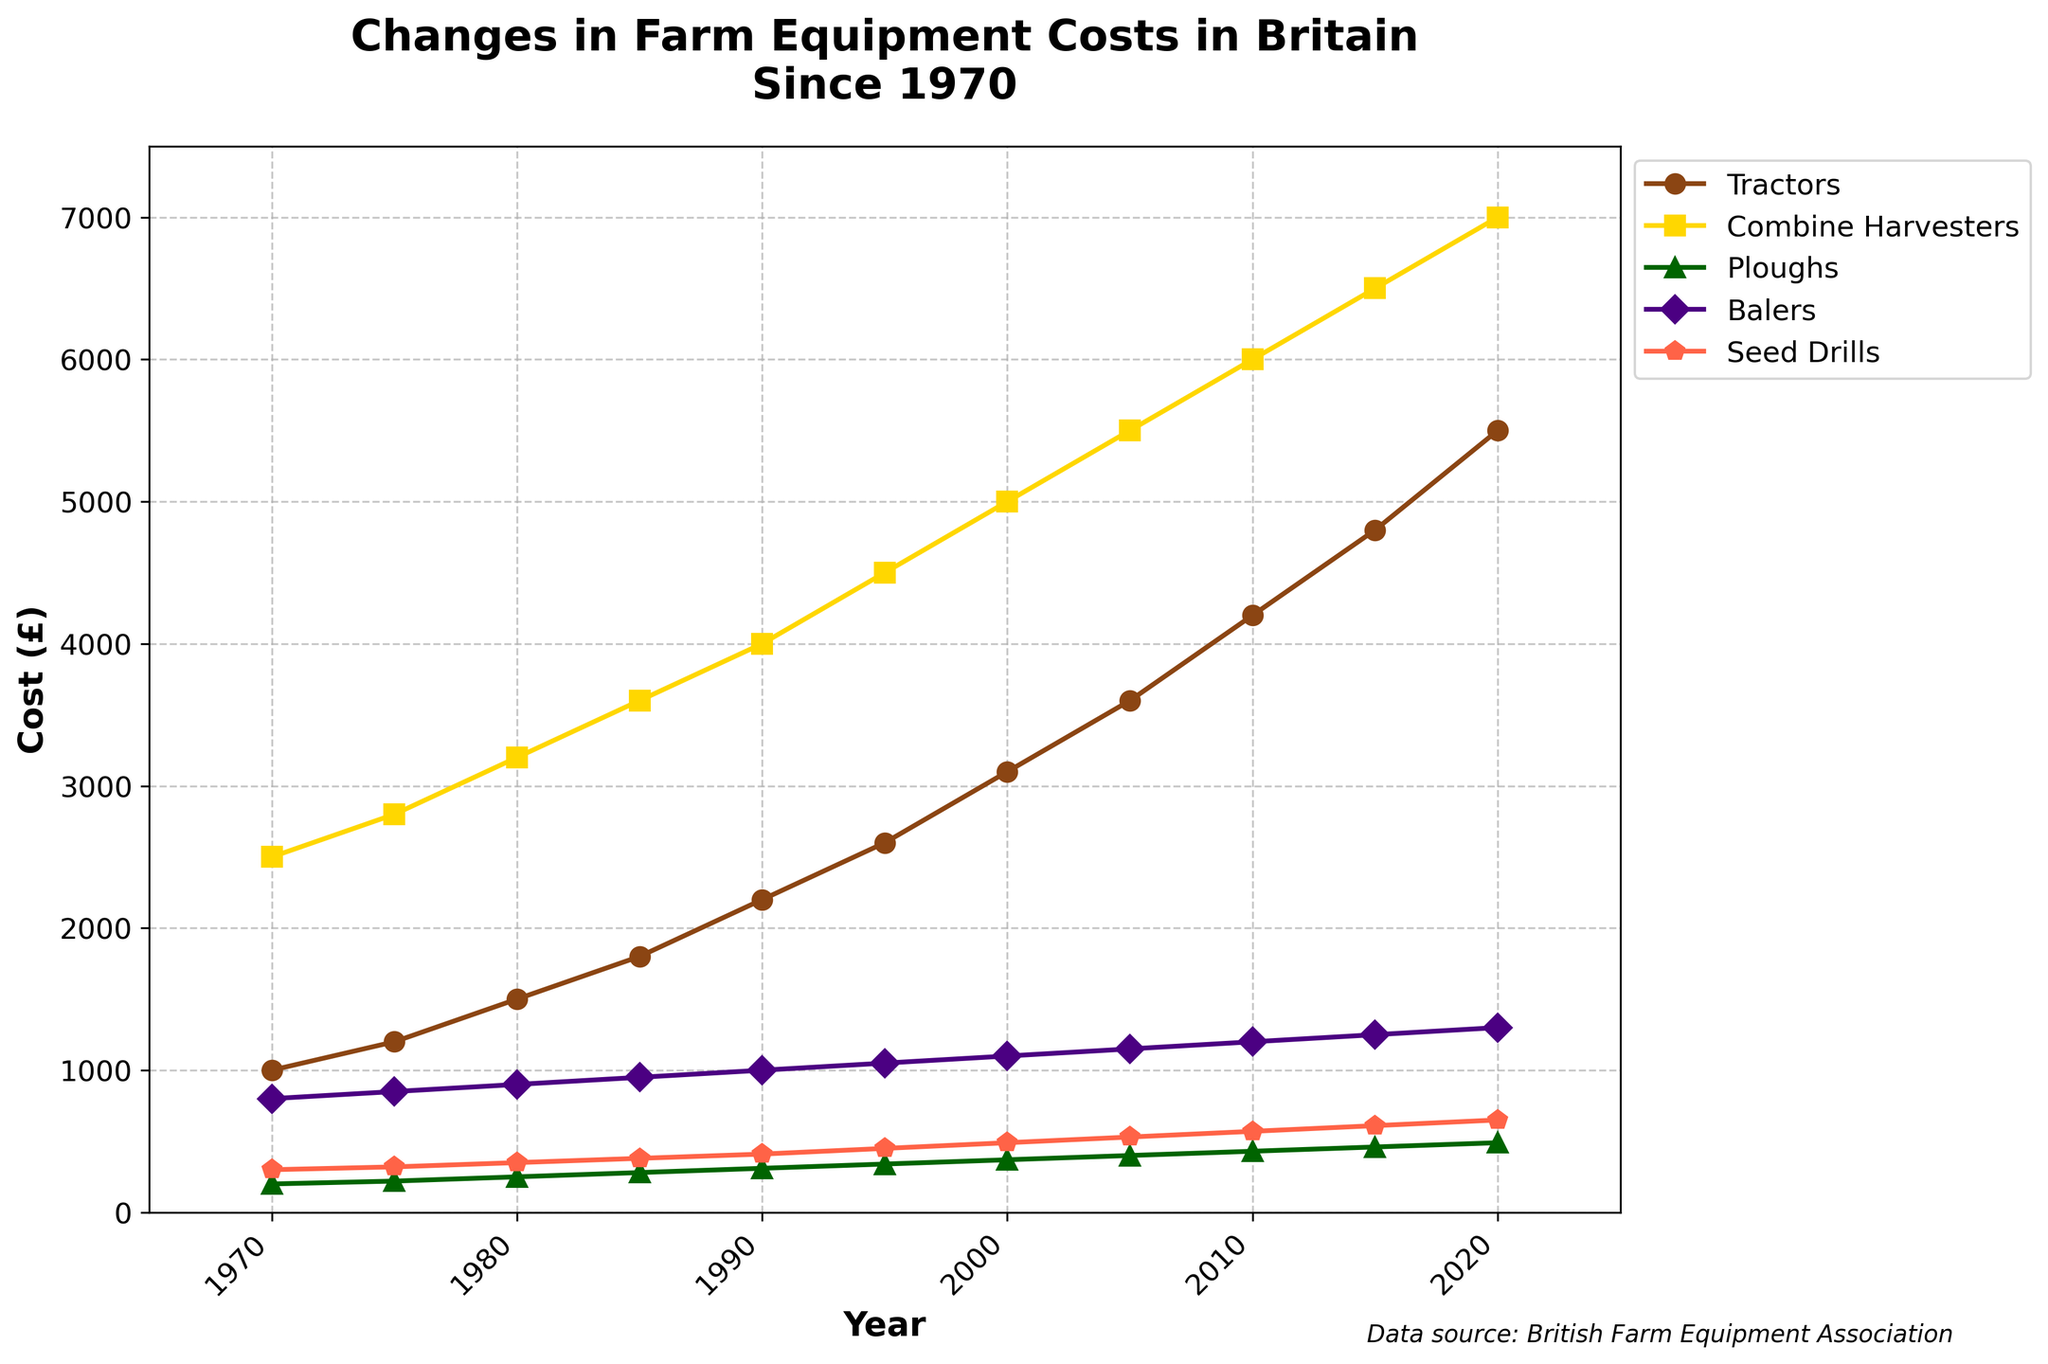What's the trend in the cost of tractors over the years? To determine the trend, look at how the data points for tractors change from 1970 to 2020. The costs increase steadily from £1,000 in 1970 to £5,500 in 2020.
Answer: Increasing Which machinery type had the lowest cost in 1970? From the figure, we can compare the costs of different machinery types in 1970. The ploughs had the lowest cost at £200.
Answer: Ploughs Between 2000 and 2010, which equipment type saw the greatest increase in cost? Calculate the cost increase for each equipment type from 2000 to 2010. Tractors increased by £1,100, Combine Harvesters by £1,000, Ploughs by £60, Balers by £100, and Seed Drills by £80. The greatest increase is for tractors.
Answer: Tractors How much did the cost of Seed Drills change from 1970 to 2020? For Seed Drills, subtract the 1970 cost from the 2020 cost: £650 - £300 = £350.
Answer: £350 Compare the costs of Combine Harvesters and Seed Drills in 1990. Which was more expensive and by how much? In 1990, Combine Harvesters cost £4,000, and Seed Drills cost £410. The difference is £4,000 - £410 = £3,590, with Combine Harvesters being more expensive.
Answer: Combine Harvesters by £3,590 What is the average cost of balers over the years shown? To find the average cost, add all the values from 1970 to 2020 and divide by the number of years: (800+850+900+950+1000+1050+1100+1150+1200+1250+1300)/11 = 1036.36.
Answer: £1036.36 In what year did the cost of Ploughs surpass £300? Review the costs of Ploughs over the years. The cost surpassed £300 in 1990.
Answer: 1990 Which equipment had the steady increase in cost from 1970 to 2020 and never decreased? Examining the plot shows that all machinery types (Tractors, Combine Harvesters, Ploughs, Balers, Seed Drills) show a steady increase in cost without any decrease.
Answer: All What is the difference in cost between the most and the least expensive machinery types in 2020? In 2020, the most expensive machinery type is Combine Harvesters at £7,000, and the least expensive is Ploughs at £490. The difference is £7,000 - £490 = £6,510.
Answer: £6,510 During which interval did the cost of tractors increase the most significantly; 1970-1990 or 2000-2020? Calculate the increase for each interval: 1970-1990 is £2,200 - £1,000 = £1,200 and 2000-2020 is £5,500 - £3,100 = £2,400. The increase is more significant between 2000-2020.
Answer: 2000-2020 